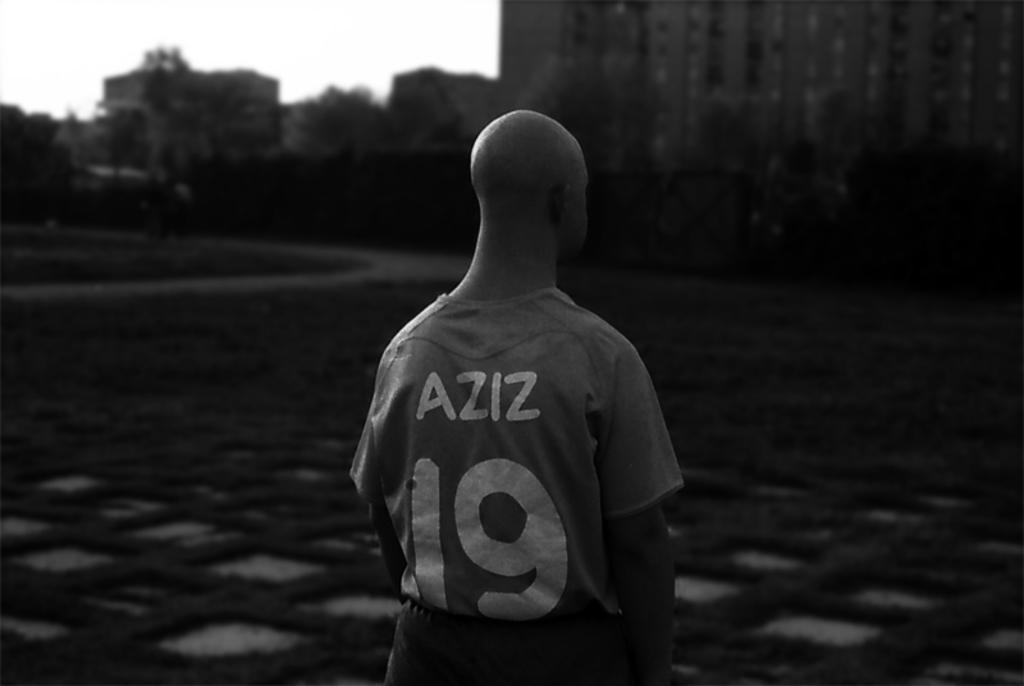What is the color scheme of the image? The image is black and white. Can you describe the main subject in the image? There is a person in the image. How would you describe the background of the image? The background is blurred, and there are buildings, trees, and the sky visible. What is the cause of the person's voice in the image? There is no voice present in the image, as it is a black and white photograph. 